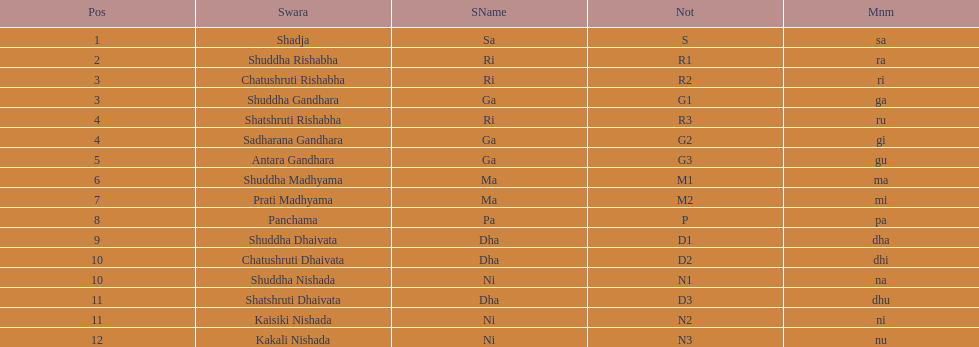What swara is above shatshruti dhaivata? Shuddha Nishada. 